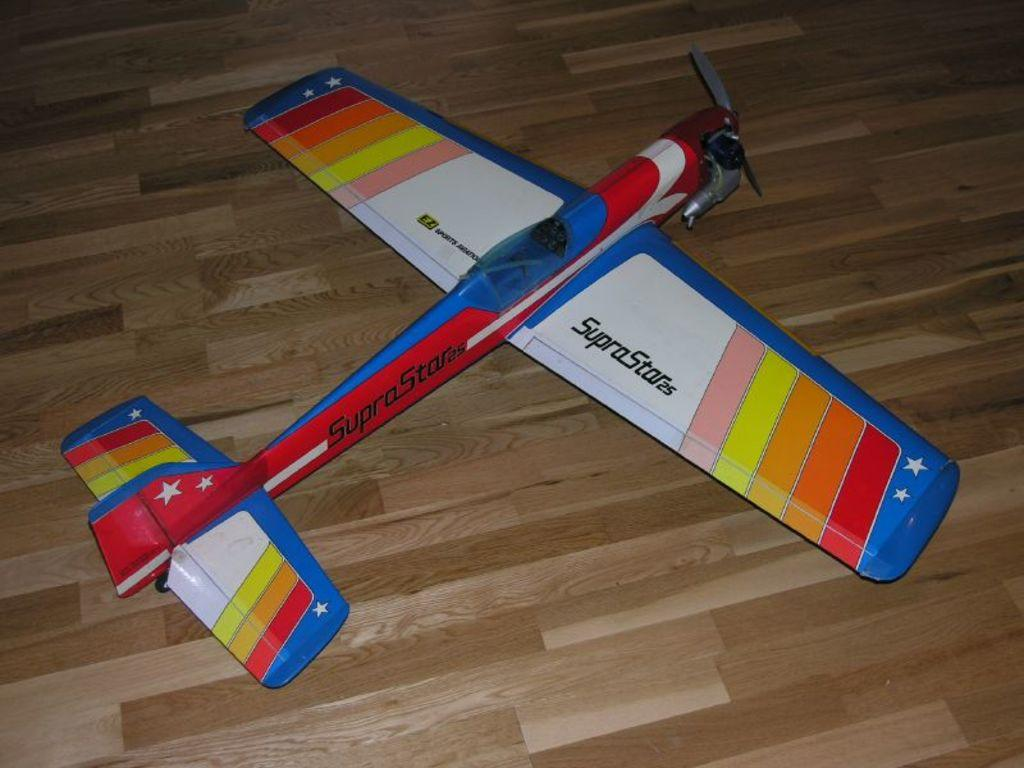What is the main object in the image? There is a toy plane in the image. What is the toy plane placed on? The toy plane is placed on a wooden surface. What type of grain is being spread on the toy plane in the image? There is no grain present in the image, and the toy plane is not being spread with any substance. 